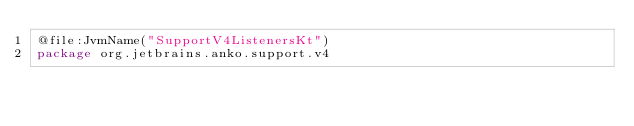<code> <loc_0><loc_0><loc_500><loc_500><_Kotlin_>@file:JvmName("SupportV4ListenersKt")
package org.jetbrains.anko.support.v4

</code> 